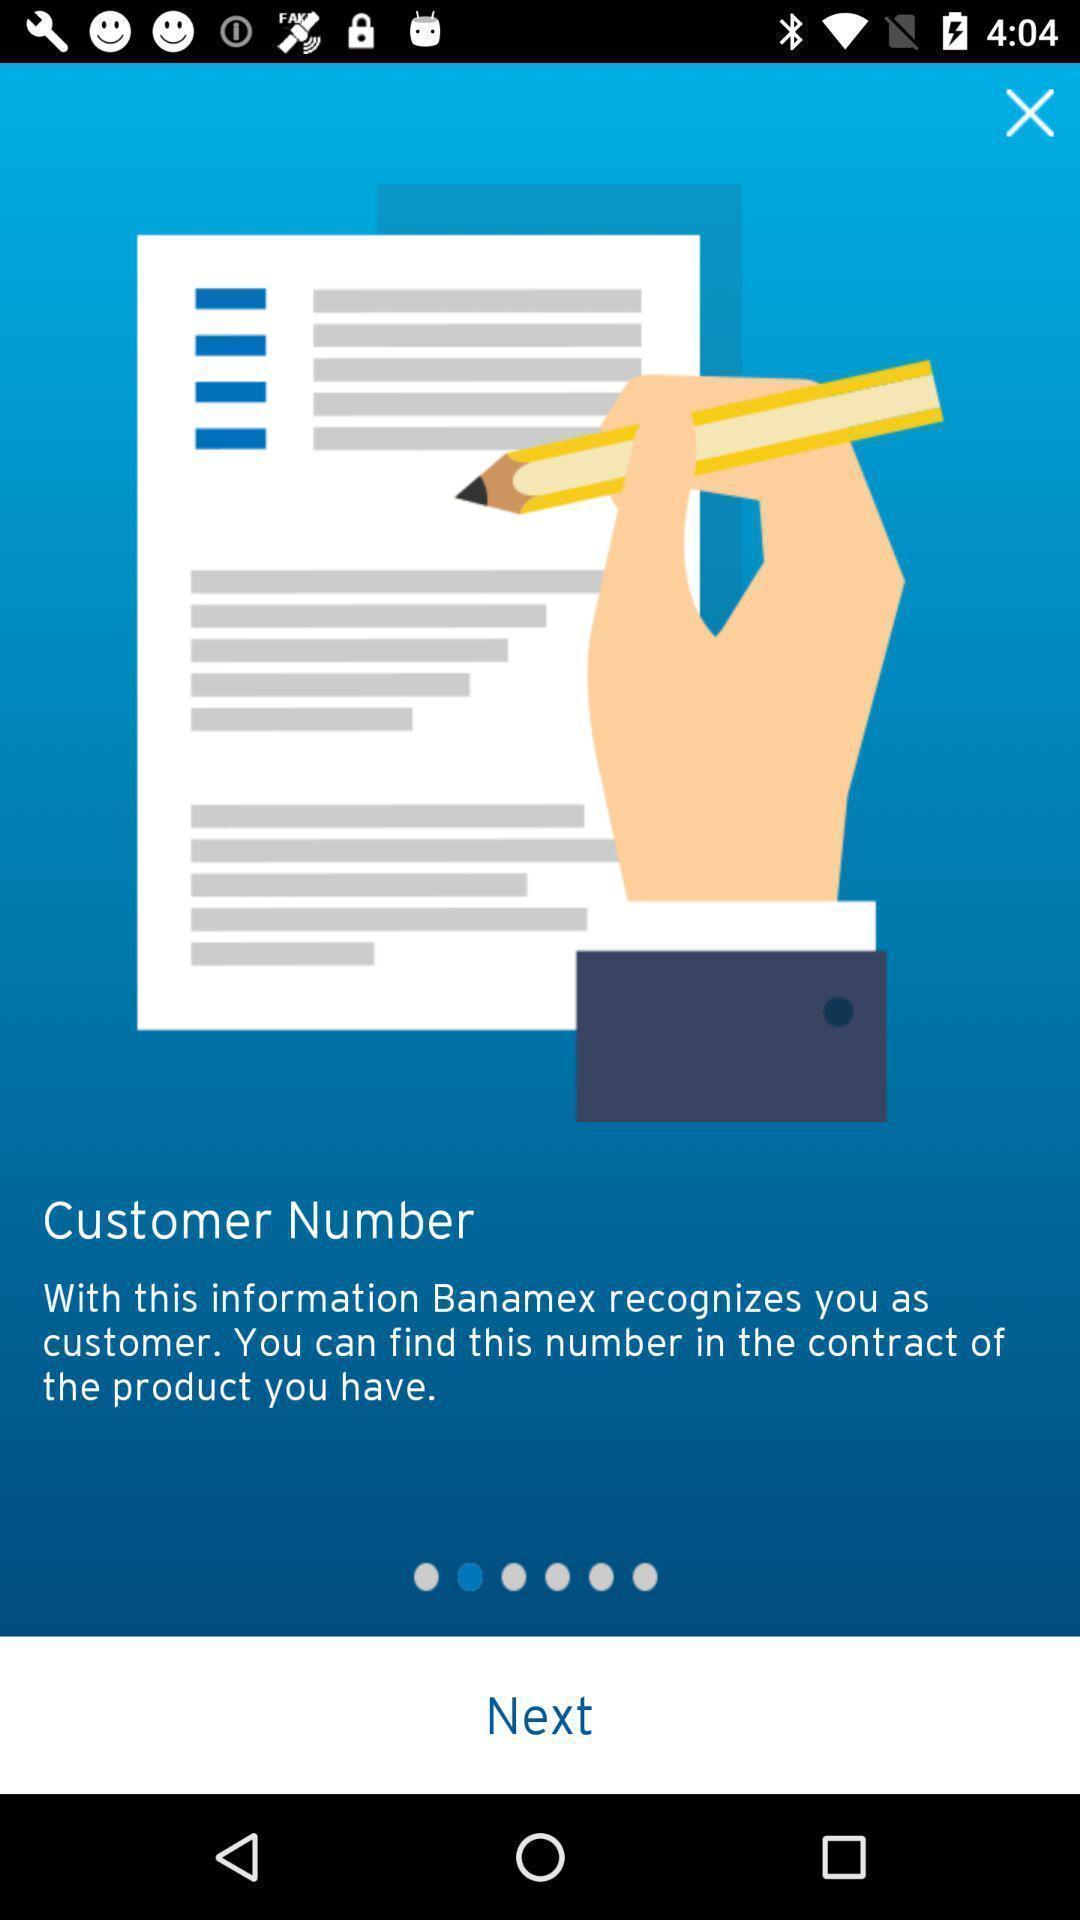Provide a textual representation of this image. Start page. 